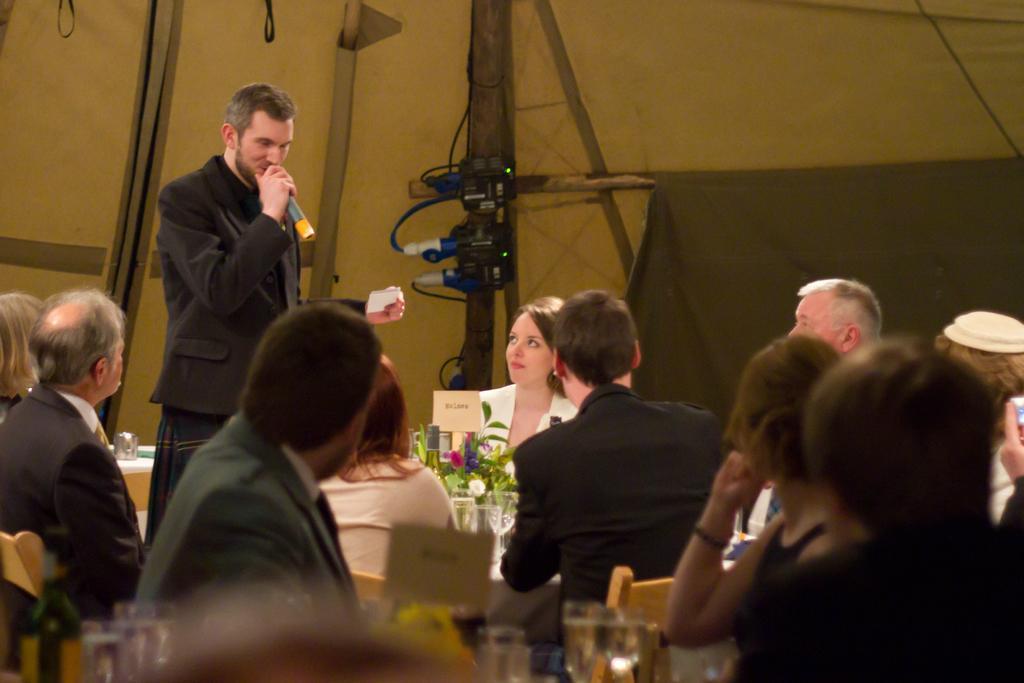Describe this image in one or two sentences. In the given image i can see a people,mike,flower pot,chairs,glasses,electronic gadget and some other objects. 